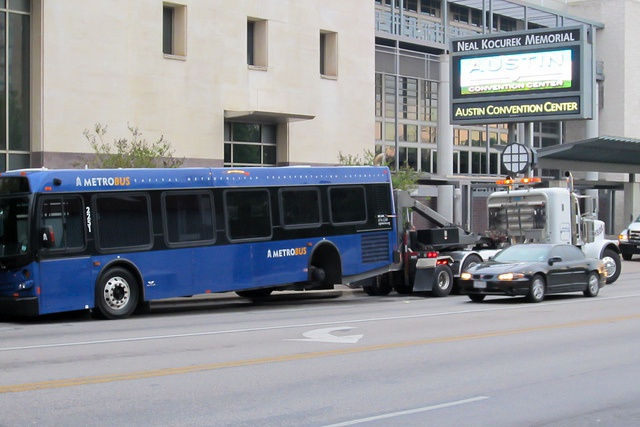Describe the objects in this image and their specific colors. I can see bus in gray, black, blue, and navy tones, truck in gray, darkgray, lightgray, and black tones, car in gray, black, darkgray, and lightblue tones, and truck in gray, black, lightgray, and darkgray tones in this image. 